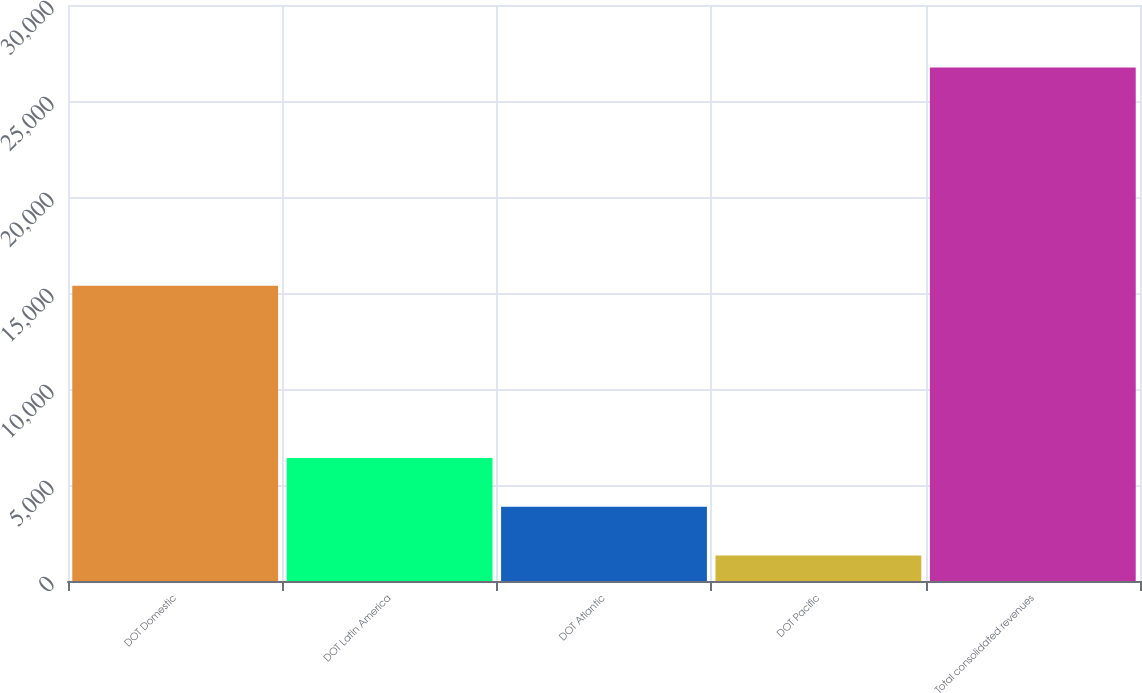Convert chart. <chart><loc_0><loc_0><loc_500><loc_500><bar_chart><fcel>DOT Domestic<fcel>DOT Latin America<fcel>DOT Atlantic<fcel>DOT Pacific<fcel>Total consolidated revenues<nl><fcel>15376<fcel>6407<fcel>3865<fcel>1323<fcel>26743<nl></chart> 